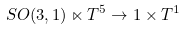Convert formula to latex. <formula><loc_0><loc_0><loc_500><loc_500>S O ( 3 , 1 ) \ltimes T ^ { 5 } \rightarrow 1 \times T ^ { 1 }</formula> 